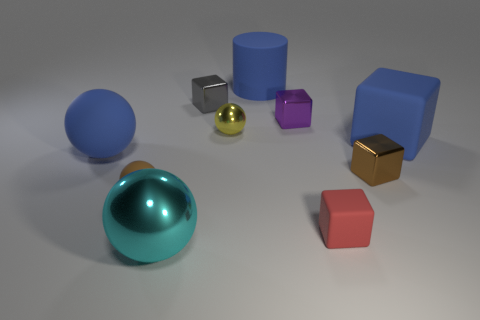Subtract all red matte blocks. How many blocks are left? 4 Subtract all blue cubes. How many cubes are left? 4 Subtract 1 balls. How many balls are left? 3 Subtract all gray spheres. Subtract all gray cylinders. How many spheres are left? 4 Subtract all cylinders. How many objects are left? 9 Add 5 large blue cylinders. How many large blue cylinders are left? 6 Add 3 big cyan shiny things. How many big cyan shiny things exist? 4 Subtract 0 gray cylinders. How many objects are left? 10 Subtract all big purple metallic spheres. Subtract all small purple shiny things. How many objects are left? 9 